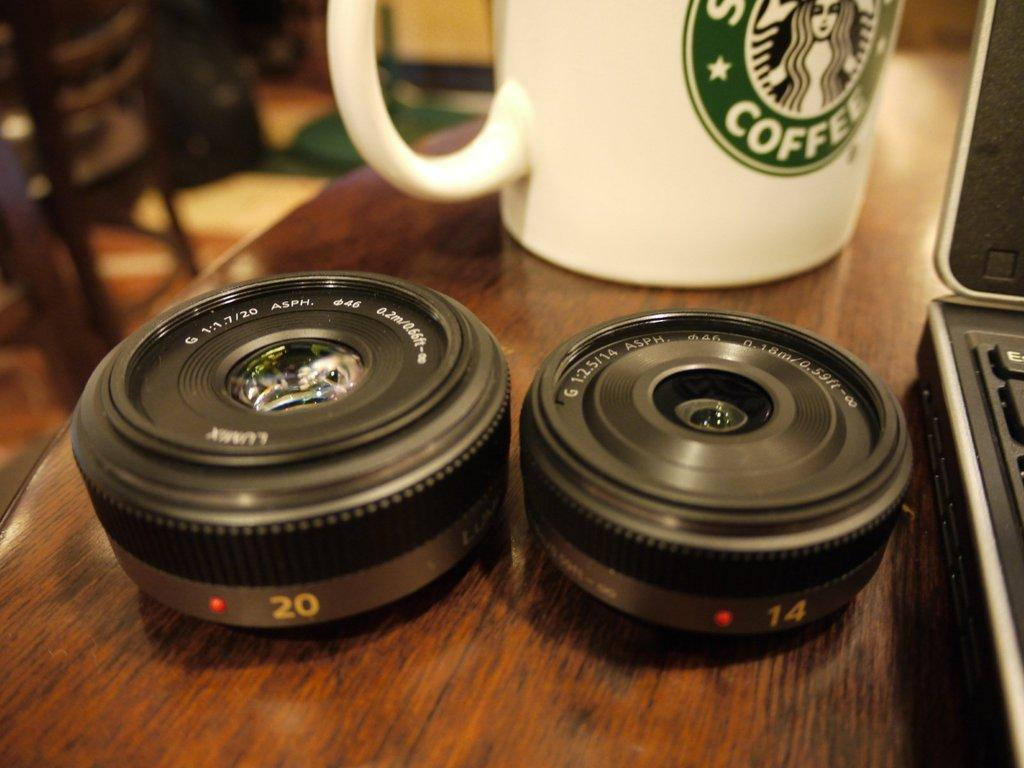What objects are present in the image that resemble lenses? There are two lenses in the image. What is on the table in the image? There is a coffee mug and a laptop on the table in the image. Can you describe the background of the image? There is a chair in the background of the image. What type of crayon is being used to draw on the laptop in the image? There is no crayon present in the image, and the laptop is not being used for drawing. 